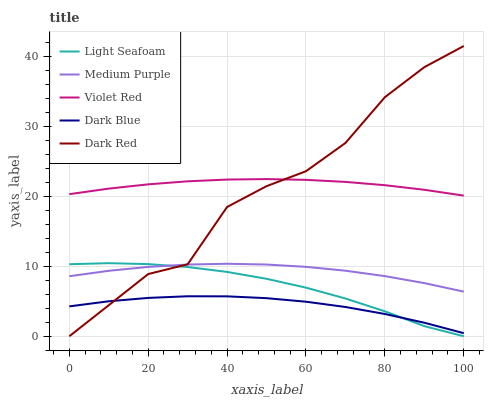Does Dark Blue have the minimum area under the curve?
Answer yes or no. Yes. Does Violet Red have the maximum area under the curve?
Answer yes or no. Yes. Does Violet Red have the minimum area under the curve?
Answer yes or no. No. Does Dark Blue have the maximum area under the curve?
Answer yes or no. No. Is Violet Red the smoothest?
Answer yes or no. Yes. Is Dark Red the roughest?
Answer yes or no. Yes. Is Dark Blue the smoothest?
Answer yes or no. No. Is Dark Blue the roughest?
Answer yes or no. No. Does Light Seafoam have the lowest value?
Answer yes or no. Yes. Does Dark Blue have the lowest value?
Answer yes or no. No. Does Dark Red have the highest value?
Answer yes or no. Yes. Does Violet Red have the highest value?
Answer yes or no. No. Is Light Seafoam less than Violet Red?
Answer yes or no. Yes. Is Violet Red greater than Light Seafoam?
Answer yes or no. Yes. Does Dark Red intersect Dark Blue?
Answer yes or no. Yes. Is Dark Red less than Dark Blue?
Answer yes or no. No. Is Dark Red greater than Dark Blue?
Answer yes or no. No. Does Light Seafoam intersect Violet Red?
Answer yes or no. No. 